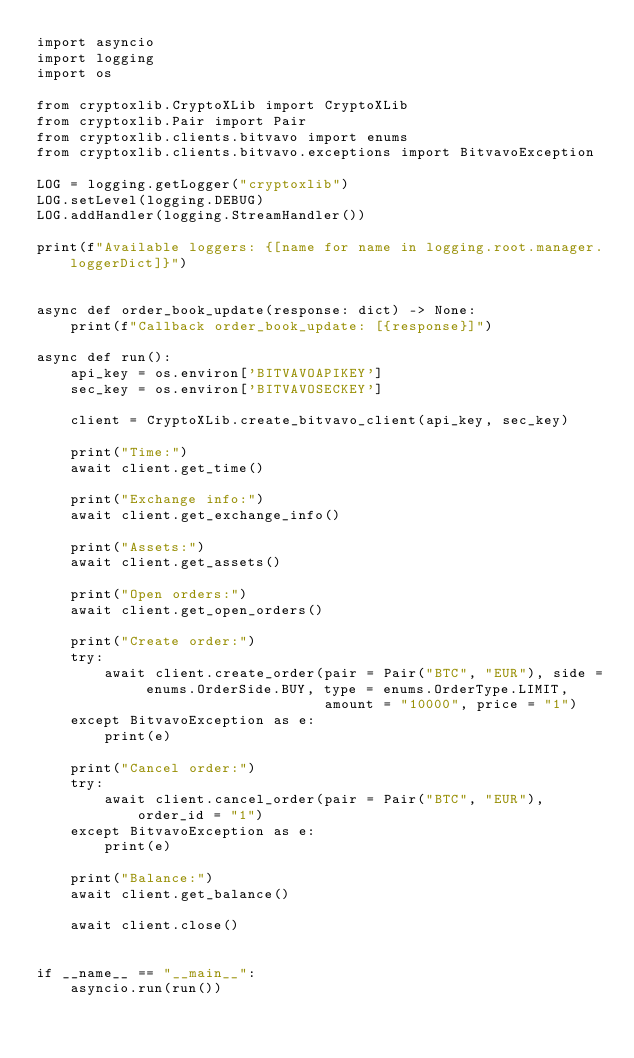<code> <loc_0><loc_0><loc_500><loc_500><_Python_>import asyncio
import logging
import os

from cryptoxlib.CryptoXLib import CryptoXLib
from cryptoxlib.Pair import Pair
from cryptoxlib.clients.bitvavo import enums
from cryptoxlib.clients.bitvavo.exceptions import BitvavoException

LOG = logging.getLogger("cryptoxlib")
LOG.setLevel(logging.DEBUG)
LOG.addHandler(logging.StreamHandler())

print(f"Available loggers: {[name for name in logging.root.manager.loggerDict]}")


async def order_book_update(response: dict) -> None:
    print(f"Callback order_book_update: [{response}]")

async def run():
    api_key = os.environ['BITVAVOAPIKEY']
    sec_key = os.environ['BITVAVOSECKEY']

    client = CryptoXLib.create_bitvavo_client(api_key, sec_key)

    print("Time:")
    await client.get_time()

    print("Exchange info:")
    await client.get_exchange_info()

    print("Assets:")
    await client.get_assets()

    print("Open orders:")
    await client.get_open_orders()

    print("Create order:")
    try:
        await client.create_order(pair = Pair("BTC", "EUR"), side = enums.OrderSide.BUY, type = enums.OrderType.LIMIT,
                                  amount = "10000", price = "1")
    except BitvavoException as e:
        print(e)

    print("Cancel order:")
    try:
        await client.cancel_order(pair = Pair("BTC", "EUR"), order_id = "1")
    except BitvavoException as e:
        print(e)

    print("Balance:")
    await client.get_balance()

    await client.close()


if __name__ == "__main__":
    asyncio.run(run())
</code> 